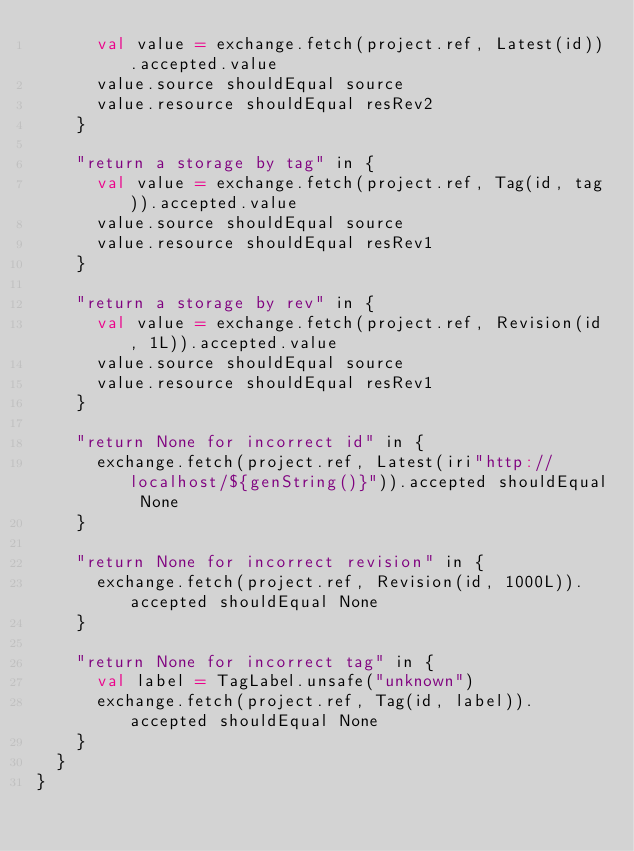<code> <loc_0><loc_0><loc_500><loc_500><_Scala_>      val value = exchange.fetch(project.ref, Latest(id)).accepted.value
      value.source shouldEqual source
      value.resource shouldEqual resRev2
    }

    "return a storage by tag" in {
      val value = exchange.fetch(project.ref, Tag(id, tag)).accepted.value
      value.source shouldEqual source
      value.resource shouldEqual resRev1
    }

    "return a storage by rev" in {
      val value = exchange.fetch(project.ref, Revision(id, 1L)).accepted.value
      value.source shouldEqual source
      value.resource shouldEqual resRev1
    }

    "return None for incorrect id" in {
      exchange.fetch(project.ref, Latest(iri"http://localhost/${genString()}")).accepted shouldEqual None
    }

    "return None for incorrect revision" in {
      exchange.fetch(project.ref, Revision(id, 1000L)).accepted shouldEqual None
    }

    "return None for incorrect tag" in {
      val label = TagLabel.unsafe("unknown")
      exchange.fetch(project.ref, Tag(id, label)).accepted shouldEqual None
    }
  }
}
</code> 